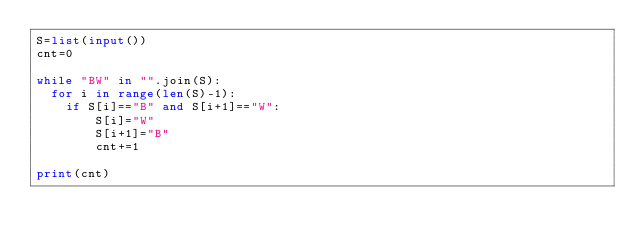Convert code to text. <code><loc_0><loc_0><loc_500><loc_500><_Python_>S=list(input())
cnt=0

while "BW" in "".join(S):
	for i in range(len(S)-1):
		if S[i]=="B" and S[i+1]=="W":
				S[i]="W"
				S[i+1]="B"
				cnt+=1

print(cnt)</code> 